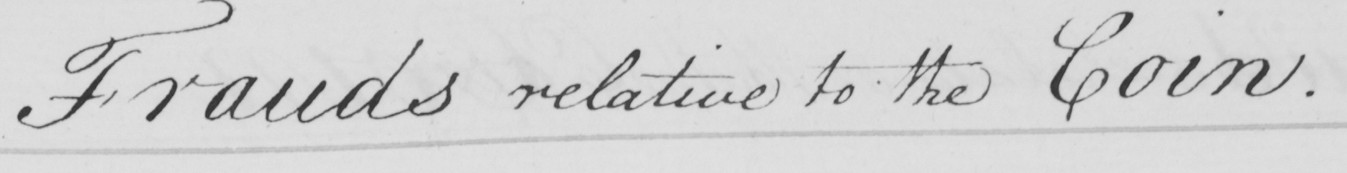Please transcribe the handwritten text in this image. Frauds relative to the Coin . 